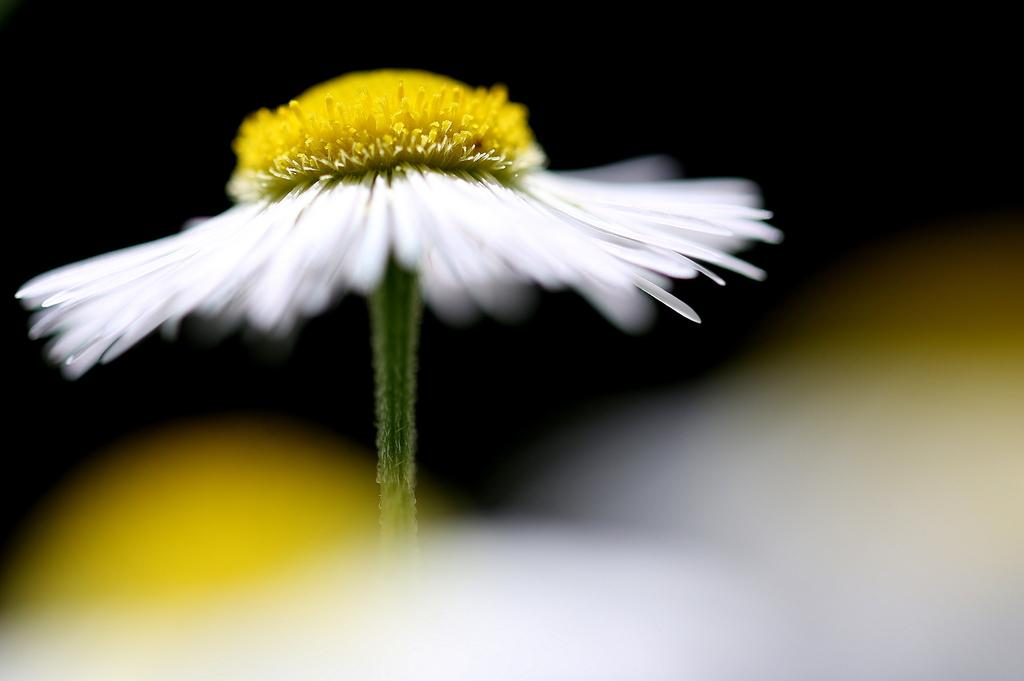What is the main subject of the image? There is a flower in the image. Can you describe the colors of the flower? The flower has white and yellow colors. What can be observed about the background of the image? The background of the image is blurred. How many visitors are present in the image? There are no visitors present in the image; it features a flower with a blurred background. What type of knot is used to tie the flower in the image? There is no knot present in the image, as it is a photograph of a flower. 